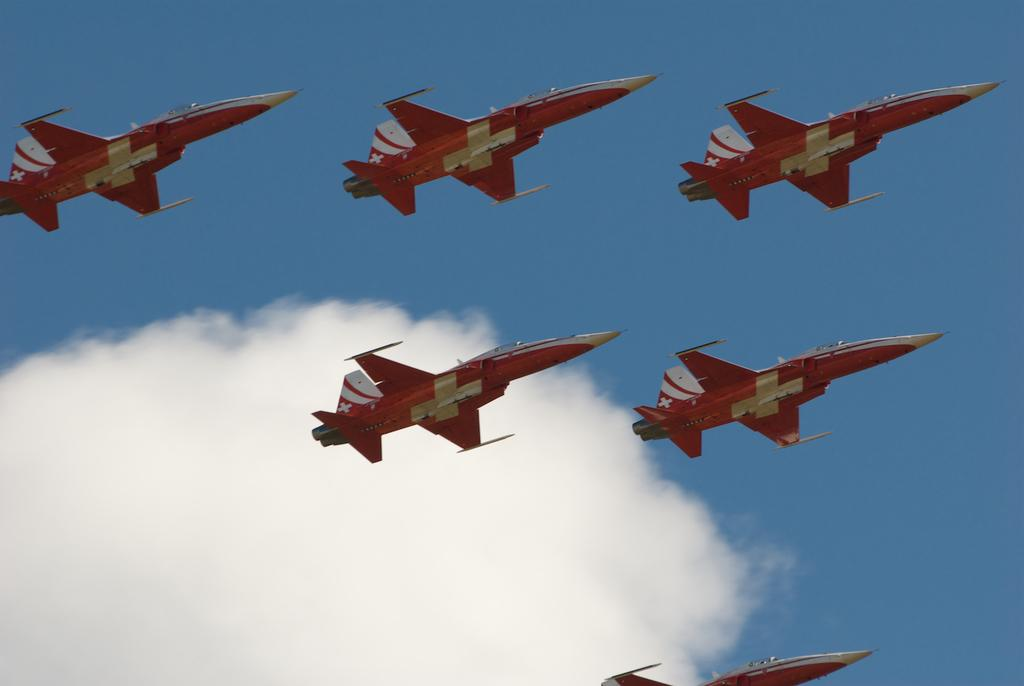How many airplanes are in the image? There are six airplanes in the image. What are the airplanes doing in the image? The airplanes are flying. What can be seen in the background of the image? There is a sky visible in the background of the image. What else is present in the sky? Clouds are present in the sky. What advice does the cook give to the horses in the image? There are no horses or cook present in the image; it features six airplanes flying in the sky. 